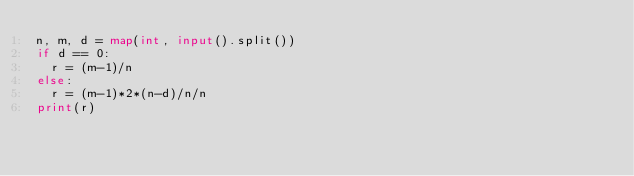Convert code to text. <code><loc_0><loc_0><loc_500><loc_500><_Python_>n, m, d = map(int, input().split())
if d == 0:
  r = (m-1)/n
else:
  r = (m-1)*2*(n-d)/n/n
print(r)
</code> 